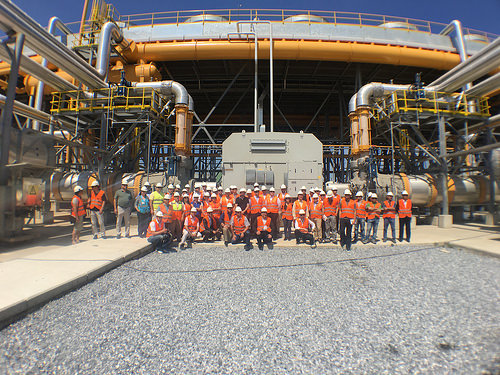<image>
Is there a man in front of the road? No. The man is not in front of the road. The spatial positioning shows a different relationship between these objects. 